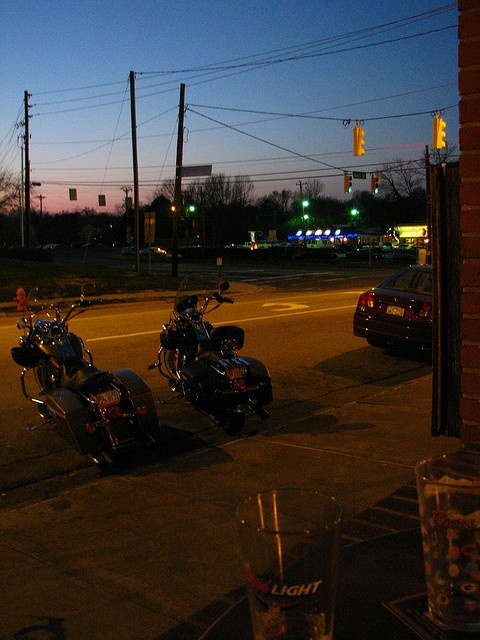Describe the objects in this image and their specific colors. I can see motorcycle in blue, black, maroon, and brown tones, cup in blue, black, maroon, and brown tones, motorcycle in blue, black, maroon, and brown tones, cup in blue, black, maroon, and brown tones, and car in blue, black, maroon, and brown tones in this image. 